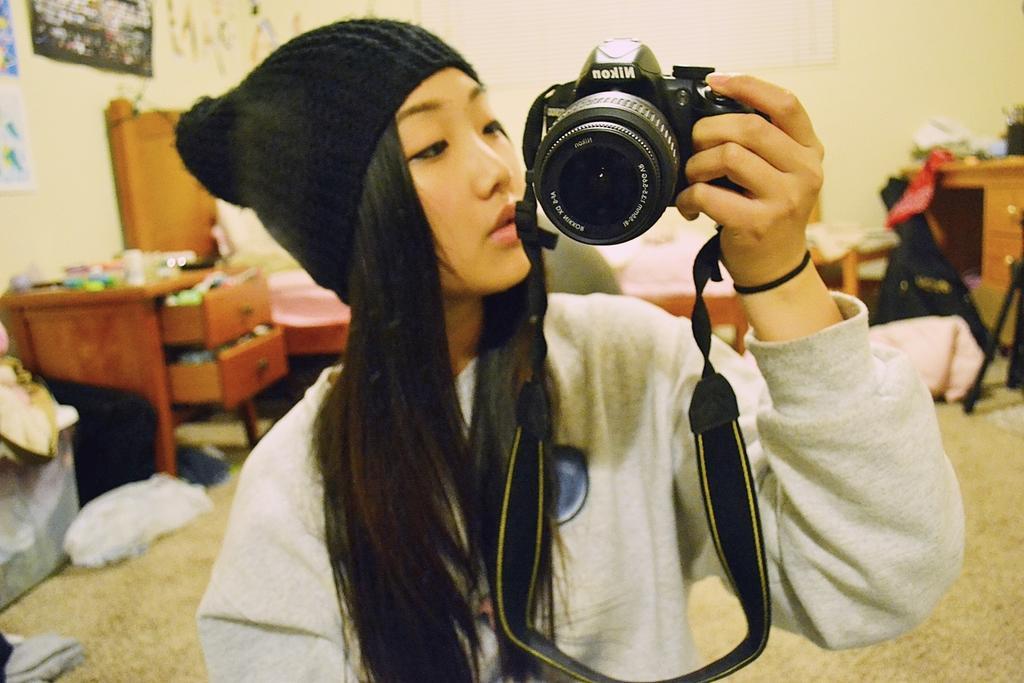Can you describe this image briefly? As we can see in the image, there is a wall, paper, photo frame and the woman who is standing in the front is holding camera. 